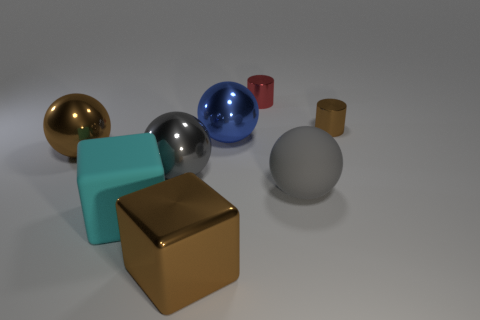There is a big sphere that is in front of the large gray thing to the left of the red shiny cylinder; how many red objects are on the right side of it?
Offer a terse response. 0. There is a gray thing left of the rubber thing that is on the right side of the big cyan object; what is its shape?
Make the answer very short. Sphere. What size is the gray metallic thing that is the same shape as the large gray rubber thing?
Provide a short and direct response. Large. What color is the large block behind the brown cube?
Give a very brief answer. Cyan. What material is the brown thing to the right of the big gray sphere to the right of the big gray ball that is behind the gray matte thing made of?
Provide a short and direct response. Metal. There is a rubber thing that is left of the large object to the right of the small red metal object; how big is it?
Offer a terse response. Large. There is a big metallic object that is the same shape as the large cyan matte thing; what is its color?
Provide a succinct answer. Brown. How many tiny metal cylinders have the same color as the big matte ball?
Keep it short and to the point. 0. Do the brown ball and the brown cube have the same size?
Keep it short and to the point. Yes. What is the cyan cube made of?
Provide a succinct answer. Rubber. 